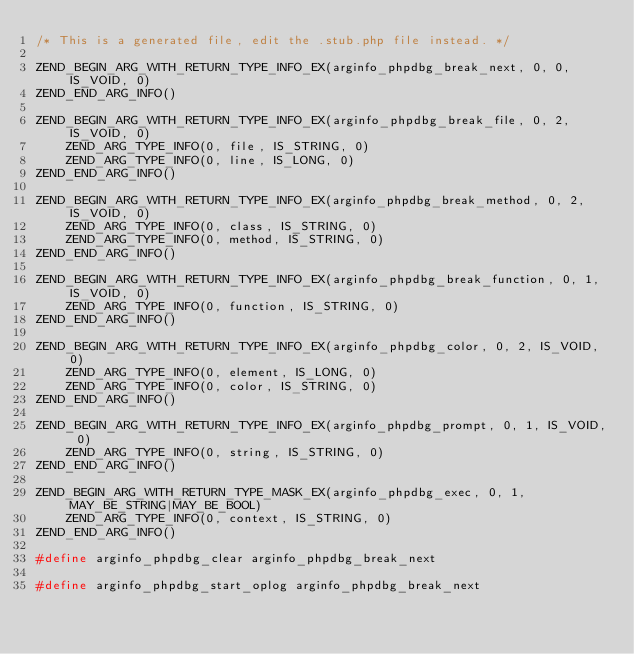<code> <loc_0><loc_0><loc_500><loc_500><_C_>/* This is a generated file, edit the .stub.php file instead. */

ZEND_BEGIN_ARG_WITH_RETURN_TYPE_INFO_EX(arginfo_phpdbg_break_next, 0, 0, IS_VOID, 0)
ZEND_END_ARG_INFO()

ZEND_BEGIN_ARG_WITH_RETURN_TYPE_INFO_EX(arginfo_phpdbg_break_file, 0, 2, IS_VOID, 0)
	ZEND_ARG_TYPE_INFO(0, file, IS_STRING, 0)
	ZEND_ARG_TYPE_INFO(0, line, IS_LONG, 0)
ZEND_END_ARG_INFO()

ZEND_BEGIN_ARG_WITH_RETURN_TYPE_INFO_EX(arginfo_phpdbg_break_method, 0, 2, IS_VOID, 0)
	ZEND_ARG_TYPE_INFO(0, class, IS_STRING, 0)
	ZEND_ARG_TYPE_INFO(0, method, IS_STRING, 0)
ZEND_END_ARG_INFO()

ZEND_BEGIN_ARG_WITH_RETURN_TYPE_INFO_EX(arginfo_phpdbg_break_function, 0, 1, IS_VOID, 0)
	ZEND_ARG_TYPE_INFO(0, function, IS_STRING, 0)
ZEND_END_ARG_INFO()

ZEND_BEGIN_ARG_WITH_RETURN_TYPE_INFO_EX(arginfo_phpdbg_color, 0, 2, IS_VOID, 0)
	ZEND_ARG_TYPE_INFO(0, element, IS_LONG, 0)
	ZEND_ARG_TYPE_INFO(0, color, IS_STRING, 0)
ZEND_END_ARG_INFO()

ZEND_BEGIN_ARG_WITH_RETURN_TYPE_INFO_EX(arginfo_phpdbg_prompt, 0, 1, IS_VOID, 0)
	ZEND_ARG_TYPE_INFO(0, string, IS_STRING, 0)
ZEND_END_ARG_INFO()

ZEND_BEGIN_ARG_WITH_RETURN_TYPE_MASK_EX(arginfo_phpdbg_exec, 0, 1, MAY_BE_STRING|MAY_BE_BOOL)
	ZEND_ARG_TYPE_INFO(0, context, IS_STRING, 0)
ZEND_END_ARG_INFO()

#define arginfo_phpdbg_clear arginfo_phpdbg_break_next

#define arginfo_phpdbg_start_oplog arginfo_phpdbg_break_next
</code> 